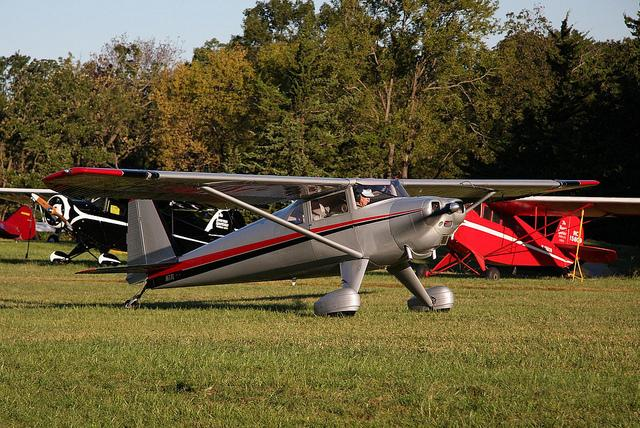What powers this plane?

Choices:
A) coal
B) kerosene
C) gasoline
D) electricity gasoline 